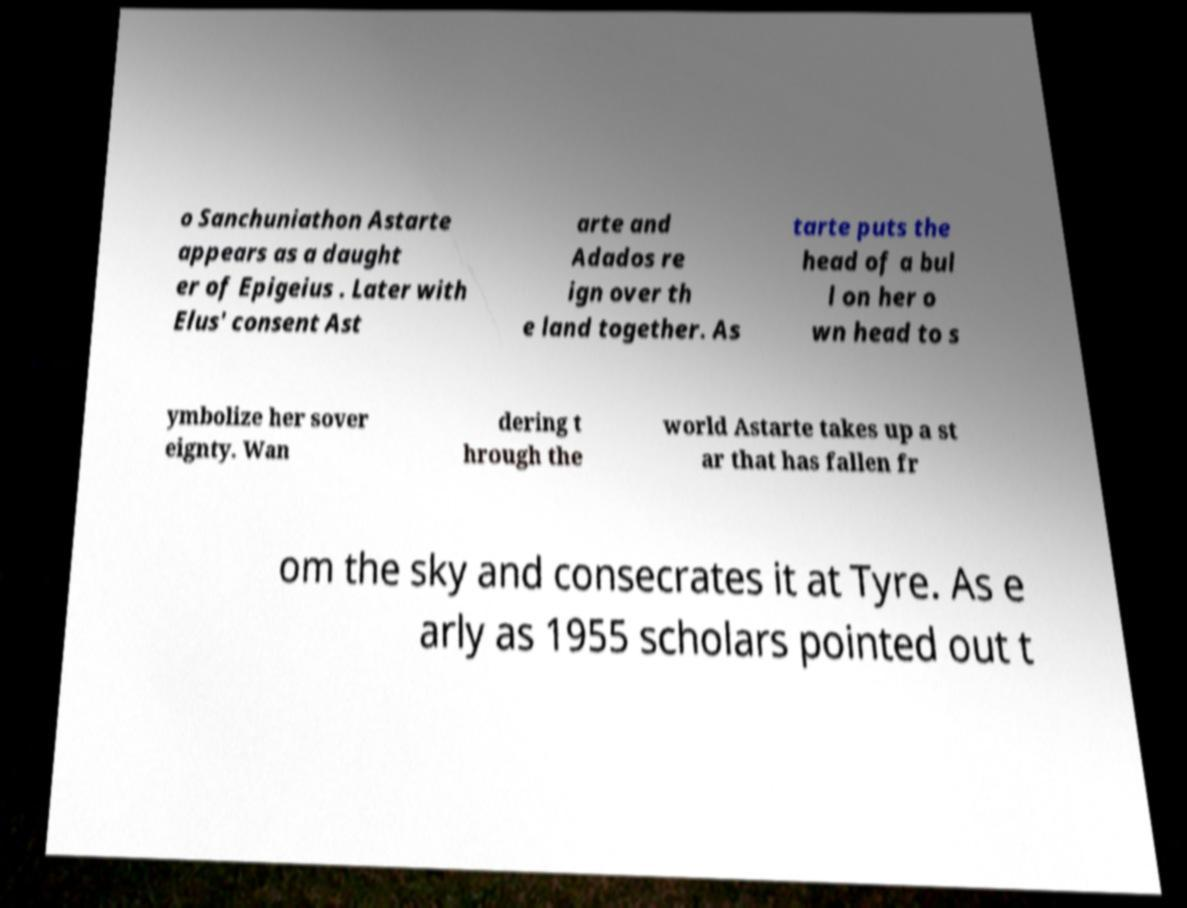Could you extract and type out the text from this image? o Sanchuniathon Astarte appears as a daught er of Epigeius . Later with Elus' consent Ast arte and Adados re ign over th e land together. As tarte puts the head of a bul l on her o wn head to s ymbolize her sover eignty. Wan dering t hrough the world Astarte takes up a st ar that has fallen fr om the sky and consecrates it at Tyre. As e arly as 1955 scholars pointed out t 